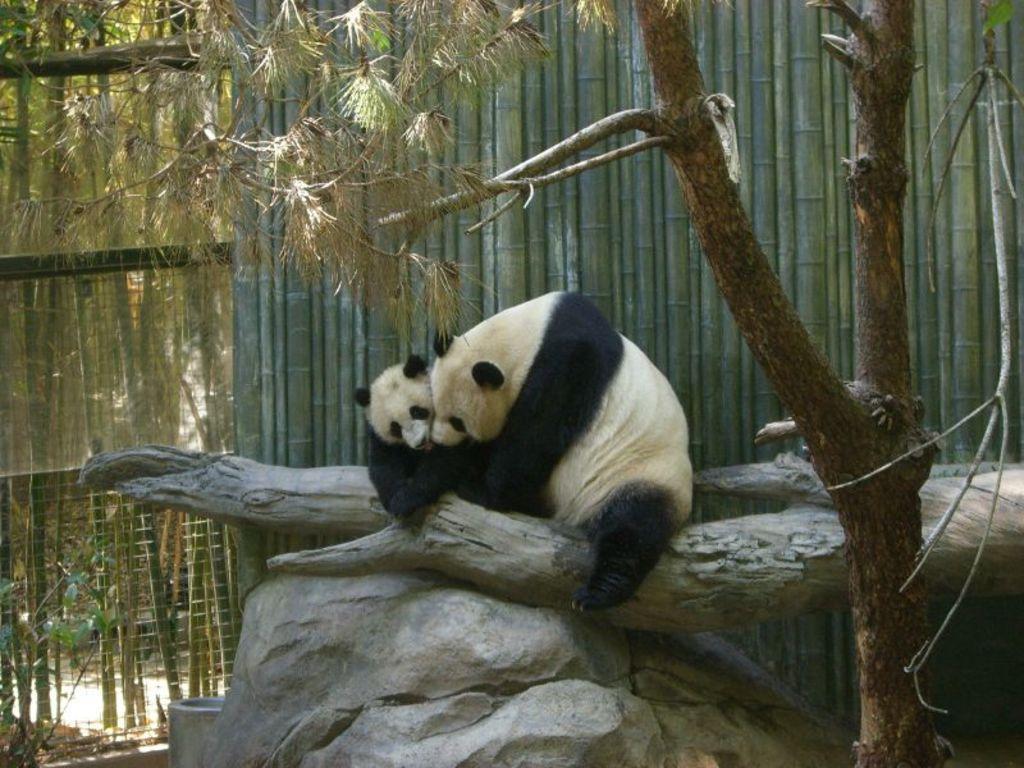Please provide a concise description of this image. In this image I can see two animals, they are in cream and black color. Background I can see few bamboo sticks, the railing and the trees are in green color. 